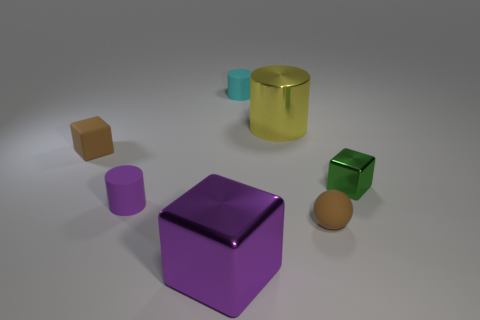Add 3 brown balls. How many objects exist? 10 Subtract all cylinders. How many objects are left? 4 Subtract 0 yellow blocks. How many objects are left? 7 Subtract all big green balls. Subtract all tiny green cubes. How many objects are left? 6 Add 7 big objects. How many big objects are left? 9 Add 5 brown blocks. How many brown blocks exist? 6 